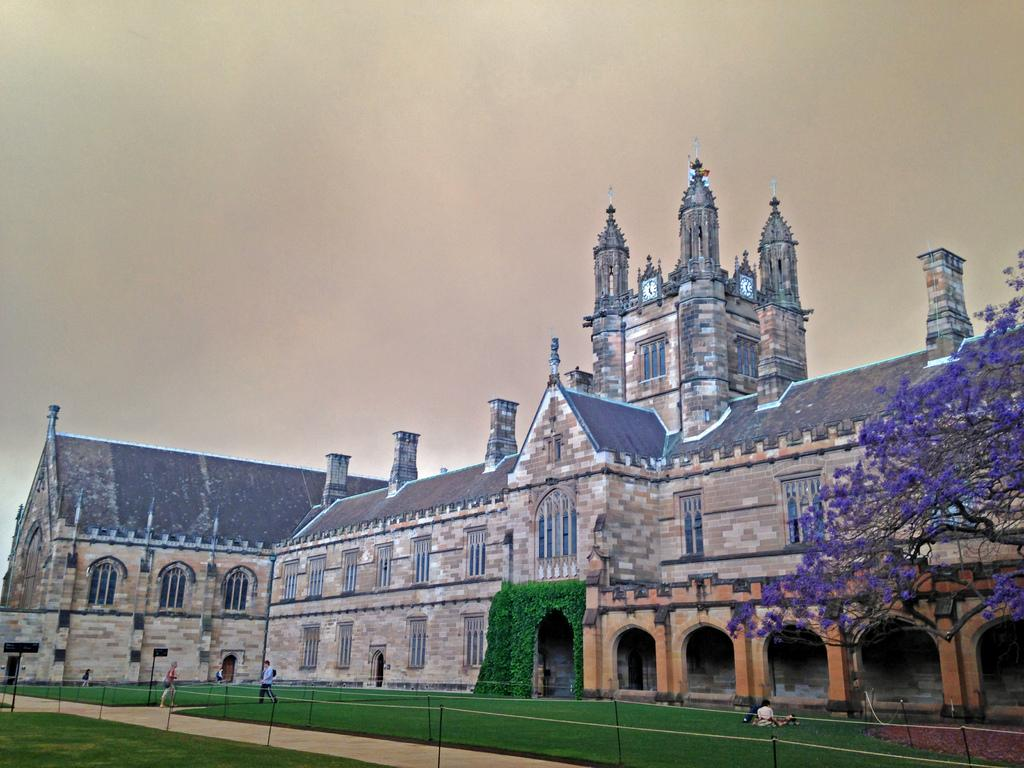What is the main structure in the middle of the image? There is a building in the middle of the image. What can be seen on the left side of the image? There are people on the left side of the image. What type of vegetation is on the right side of the image? There is a tree on the right side of the image. What is visible at the top of the image? The sky is visible at the top of the image. Can you see a plough being used by the people on the left side of the image? There is no plough present in the image; only people are visible on the left side. How many robins are perched on the tree on the right side of the image? There are no robins present in the image; only a tree is visible on the right side. 